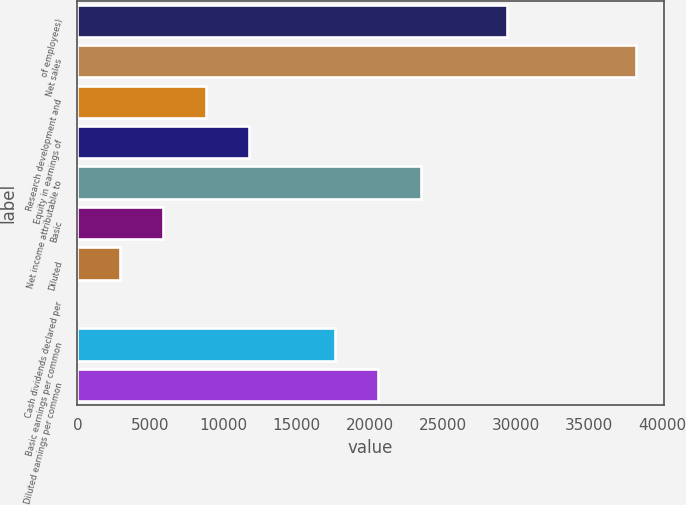Convert chart. <chart><loc_0><loc_0><loc_500><loc_500><bar_chart><fcel>of employees)<fcel>Net sales<fcel>Research development and<fcel>Equity in earnings of<fcel>Net income attributable to<fcel>Basic<fcel>Diluted<fcel>Cash dividends declared per<fcel>Basic earnings per common<fcel>Diluted earnings per common<nl><fcel>29375<fcel>38187.4<fcel>8812.73<fcel>11750.2<fcel>23500.1<fcel>5875.26<fcel>2937.79<fcel>0.32<fcel>17625.1<fcel>20562.6<nl></chart> 